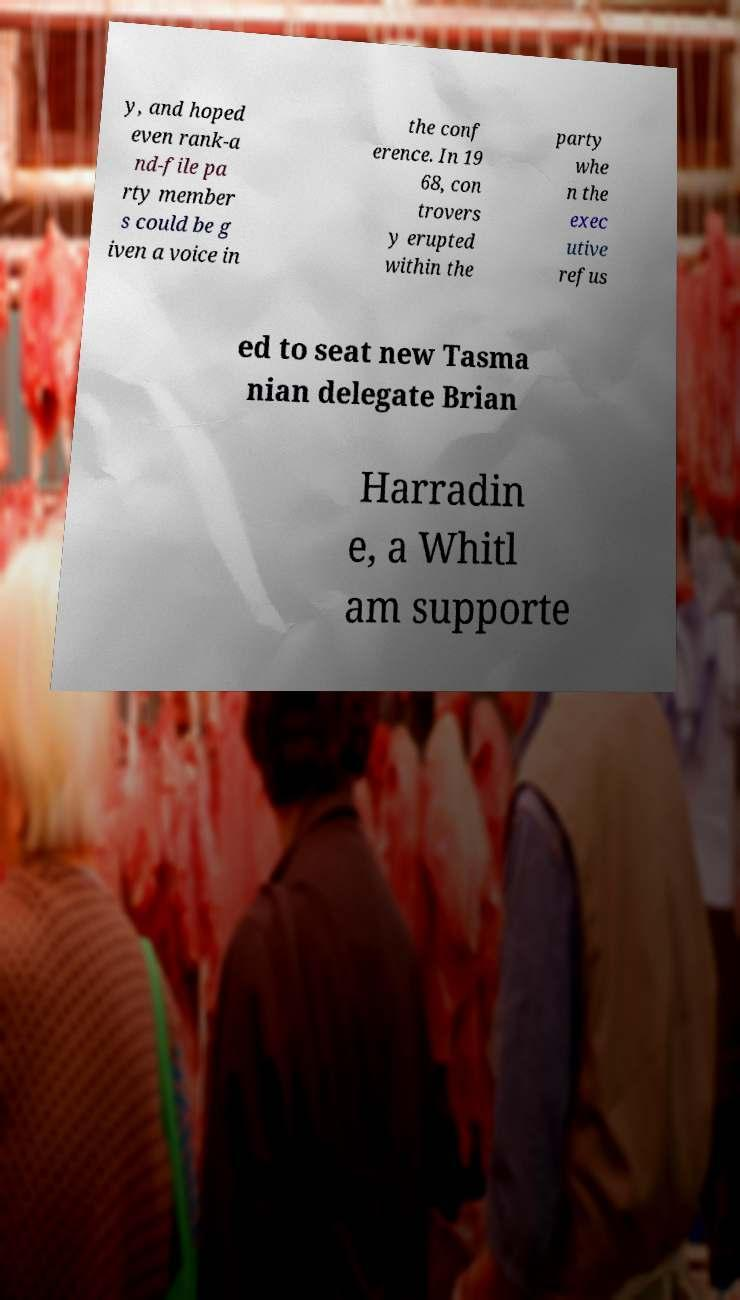Can you read and provide the text displayed in the image?This photo seems to have some interesting text. Can you extract and type it out for me? y, and hoped even rank-a nd-file pa rty member s could be g iven a voice in the conf erence. In 19 68, con trovers y erupted within the party whe n the exec utive refus ed to seat new Tasma nian delegate Brian Harradin e, a Whitl am supporte 